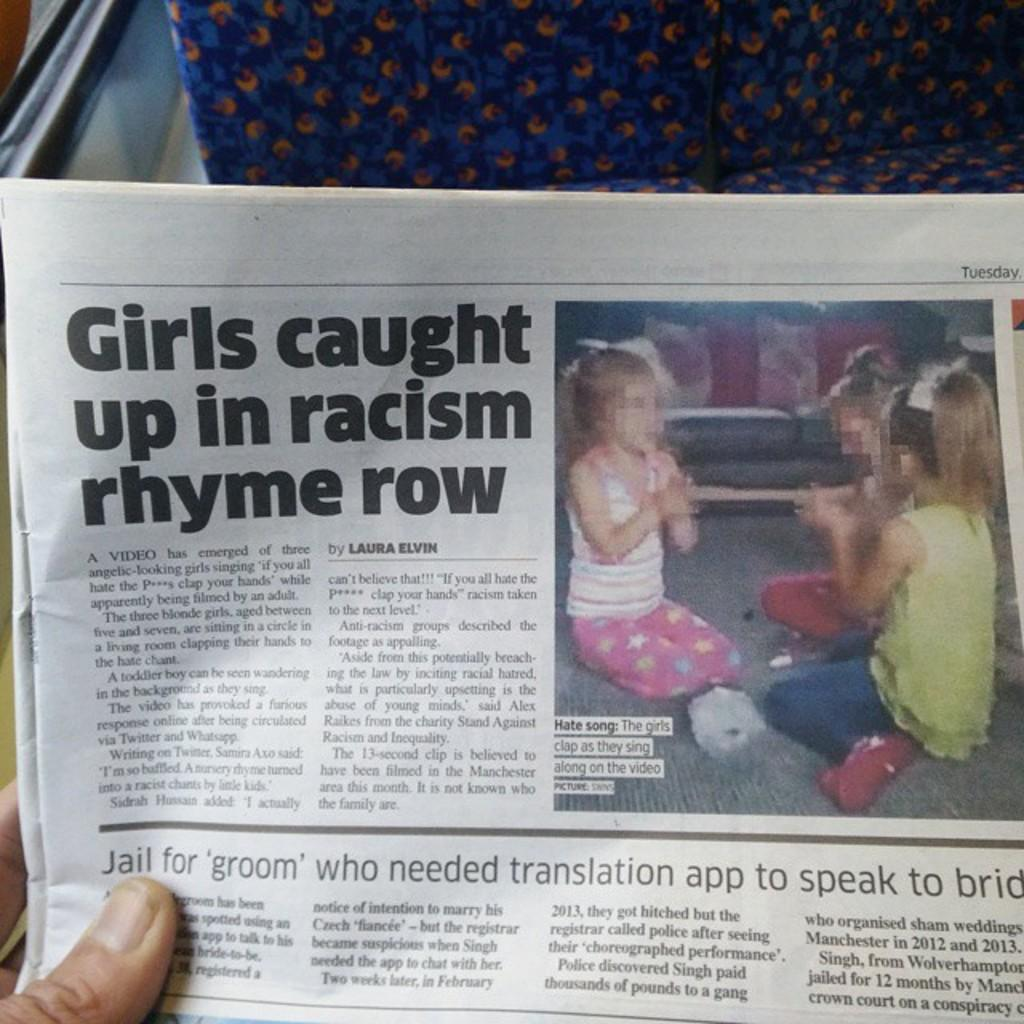What is the person in the image holding? The person is holding a newspaper in the image. What can be found within the newspaper? The newspaper contains text and images of kids. What color is the object at the top of the image? There is a violet color object at the top of the image. What type of object is located at the top left of the image? There is an iron object at the top left of the image. What type of locket is the person wearing around their neck in the image? There is no locket visible in the image; the person is holding a newspaper. How many hands are visible in the image? The number of hands visible in the image cannot be determined from the provided facts, as only the person holding the newspaper is mentioned. 